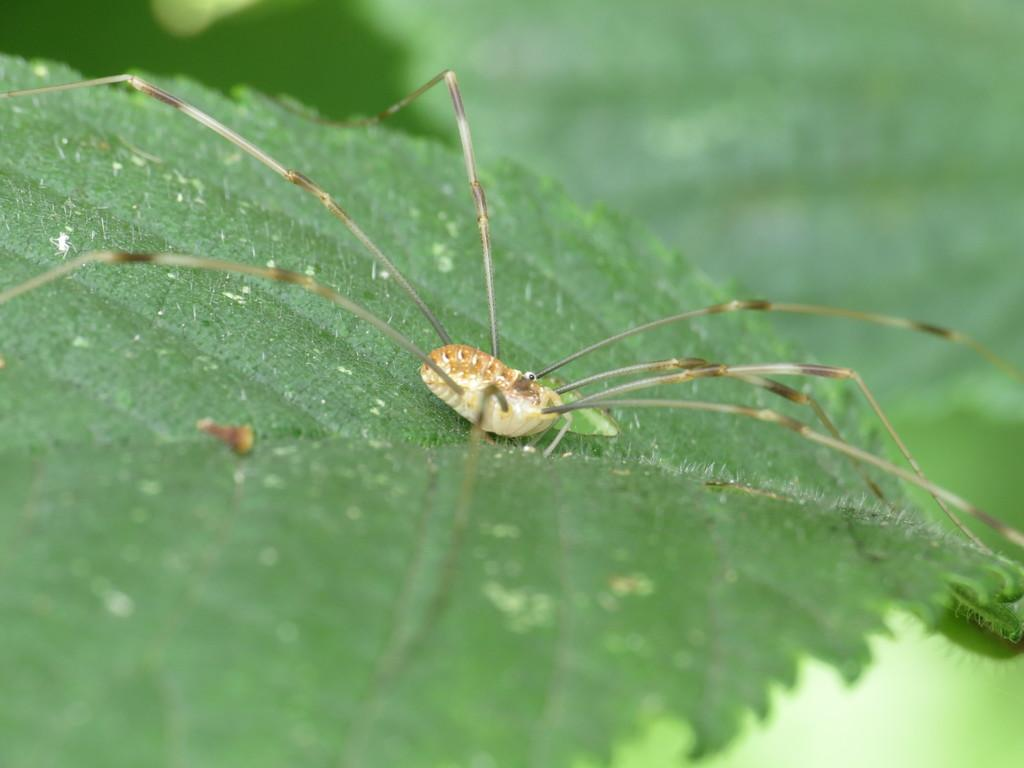What is present in the image? There is a spider in the image. Where is the spider located? The spider is on a leaf. What type of activity is the spider participating in with the frogs in the image? There are no frogs present in the image, and the spider is not participating in any activity with them. 